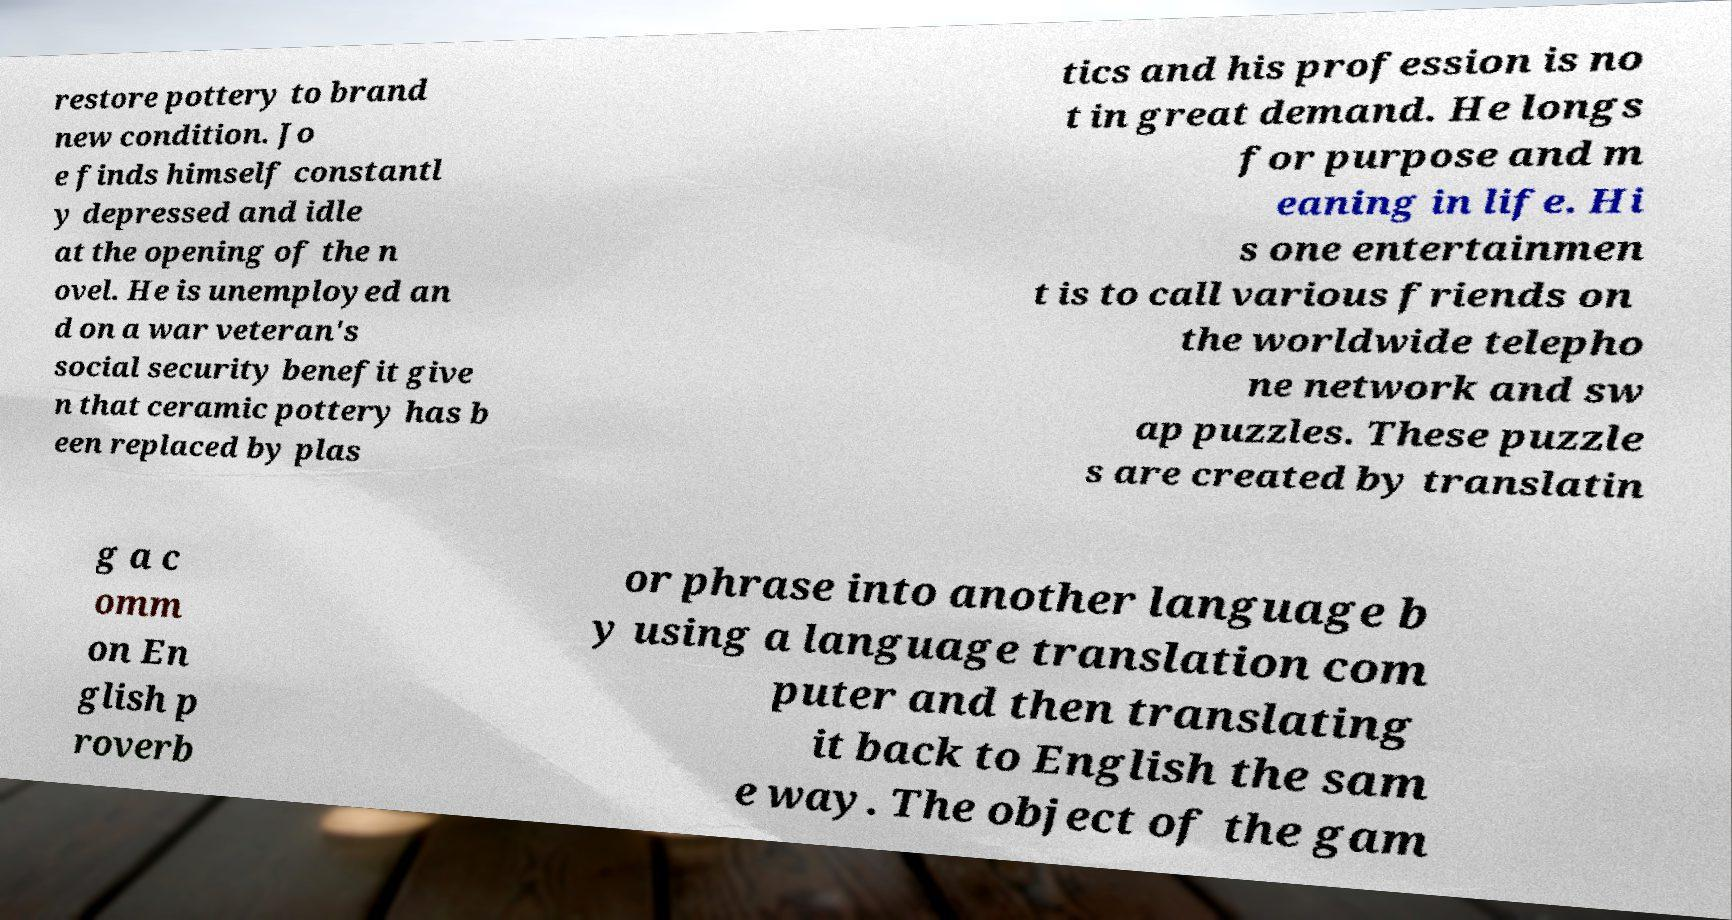I need the written content from this picture converted into text. Can you do that? restore pottery to brand new condition. Jo e finds himself constantl y depressed and idle at the opening of the n ovel. He is unemployed an d on a war veteran's social security benefit give n that ceramic pottery has b een replaced by plas tics and his profession is no t in great demand. He longs for purpose and m eaning in life. Hi s one entertainmen t is to call various friends on the worldwide telepho ne network and sw ap puzzles. These puzzle s are created by translatin g a c omm on En glish p roverb or phrase into another language b y using a language translation com puter and then translating it back to English the sam e way. The object of the gam 